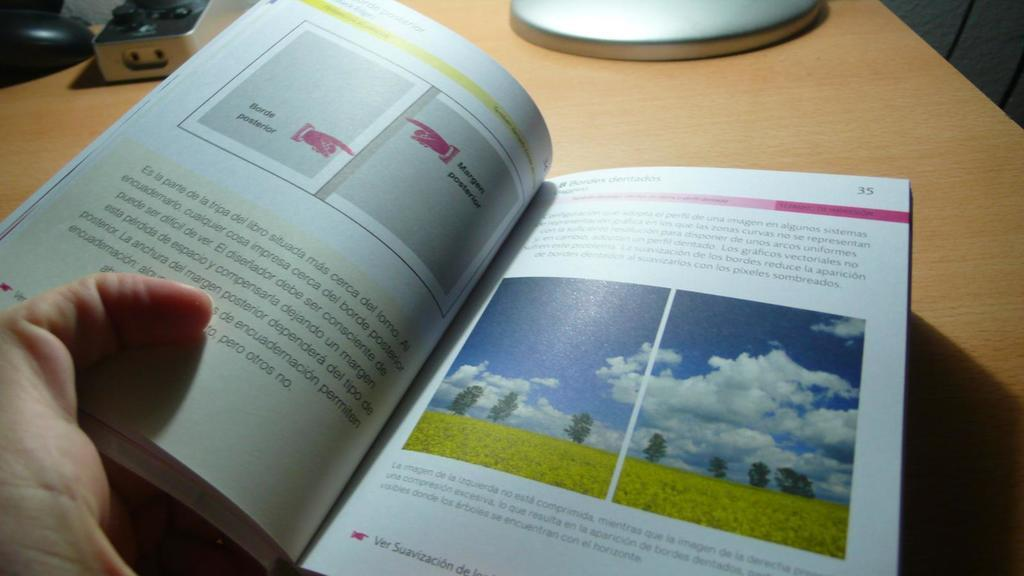<image>
Share a concise interpretation of the image provided. a book opened up to page 35 with pictures on the page of outside 